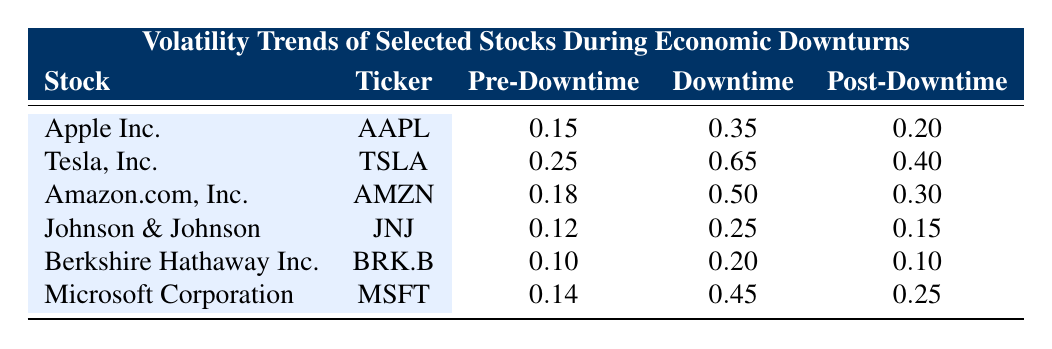What is the downtime volatility of Tesla, Inc.? The downtime volatility of Tesla, Inc. is listed in the table under the "Downtime" column for the row corresponding to Tesla, Inc. It shows a value of 0.65.
Answer: 0.65 What was the pre-downtime volatility of Johnson & Johnson? The pre-downtime volatility of Johnson & Johnson is found in the "Pre-Downtime" column for its row, where it is recorded as 0.12.
Answer: 0.12 Which stock had the highest volatility during downtime? To answer this, examine the "Downtime" column across all rows and identify the highest value. Tesla, Inc. has the highest downtime volatility of 0.65.
Answer: Tesla, Inc What is the difference between the downtime volatility of Amazon.com, Inc. and Microsoft Corporation? First, find the downtime volatility values for both companies: Amazon.com, Inc. has 0.50 and Microsoft Corporation has 0.45. The difference is 0.50 - 0.45 = 0.05.
Answer: 0.05 What was the average pre-downtime volatility for all selected stocks? To find the average pre-downtime volatility, sum the pre-downtime values (0.15 + 0.25 + 0.18 + 0.12 + 0.10 + 0.14 = 0.94) and divide by the number of stocks (6). Thus, the average is 0.94 / 6 = 0.1567, which rounds to 0.16.
Answer: 0.16 Did any stock maintain the same volatility level before and after the downtime? By comparing the "Pre-Downtime" and "Post-Downtime" columns for all stocks, it shows that Berkshire Hathaway Inc. has the same post-downtime volatility (0.10) as its pre-downtime volatility (0.10). Thus, the answer is yes.
Answer: Yes Which stock experienced an increase in volatility from pre-downtime to downtime? Assess each stock's pre-downtime and downtime values. The stocks that show an increase are Apple Inc. (0.15 to 0.35), Tesla, Inc. (0.25 to 0.65), Amazon.com, Inc. (0.18 to 0.50), and Microsoft Corporation (0.14 to 0.45). Therefore, the answer includes all these stocks.
Answer: Apple Inc., Tesla, Inc., Amazon.com, Inc., Microsoft Corporation How much did Apple Inc.'s volatility decrease from downtime to post-downtime? First, find the values: Apple Inc.'s downtime volatility is 0.35 and post-downtime volatility is 0.20. The change is 0.35 - 0.20 = 0.15.
Answer: 0.15 